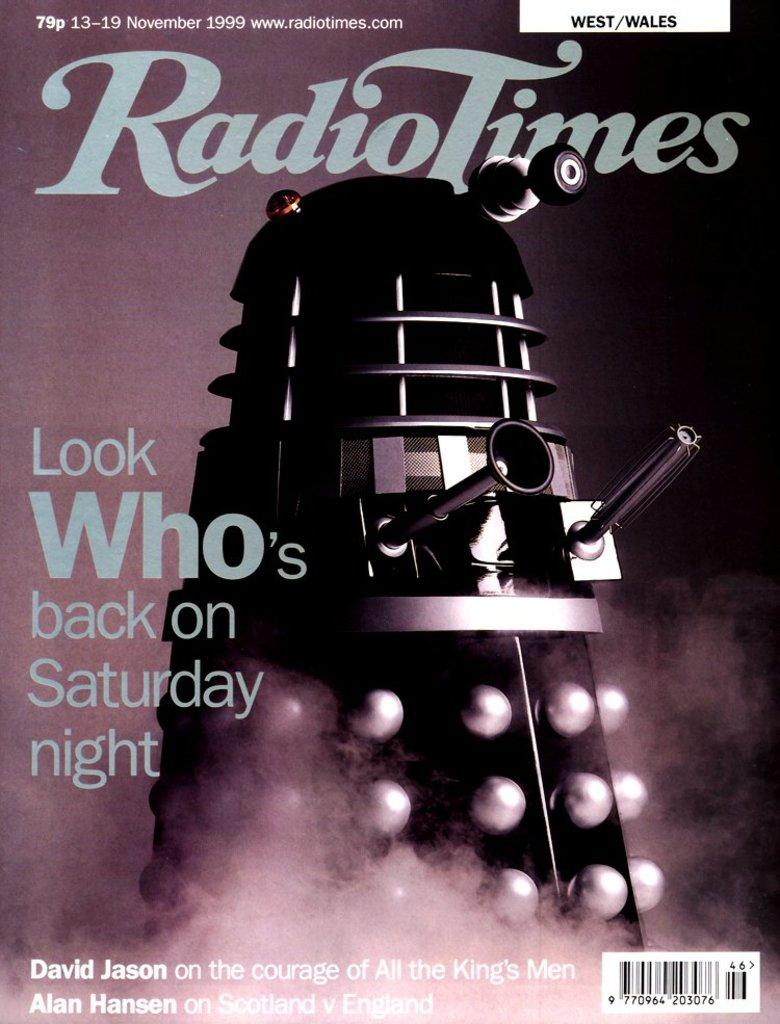<image>
Render a clear and concise summary of the photo. A Novemeber 1999 edition of RadioTimes magazine with the cover story "Loo Who's back on Saturday night". 